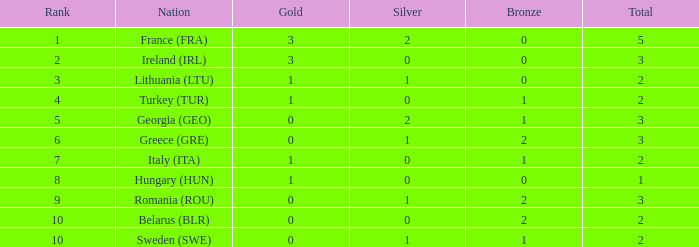What is the sum of sweden (swe) possessing fewer than 1 silver? None. 